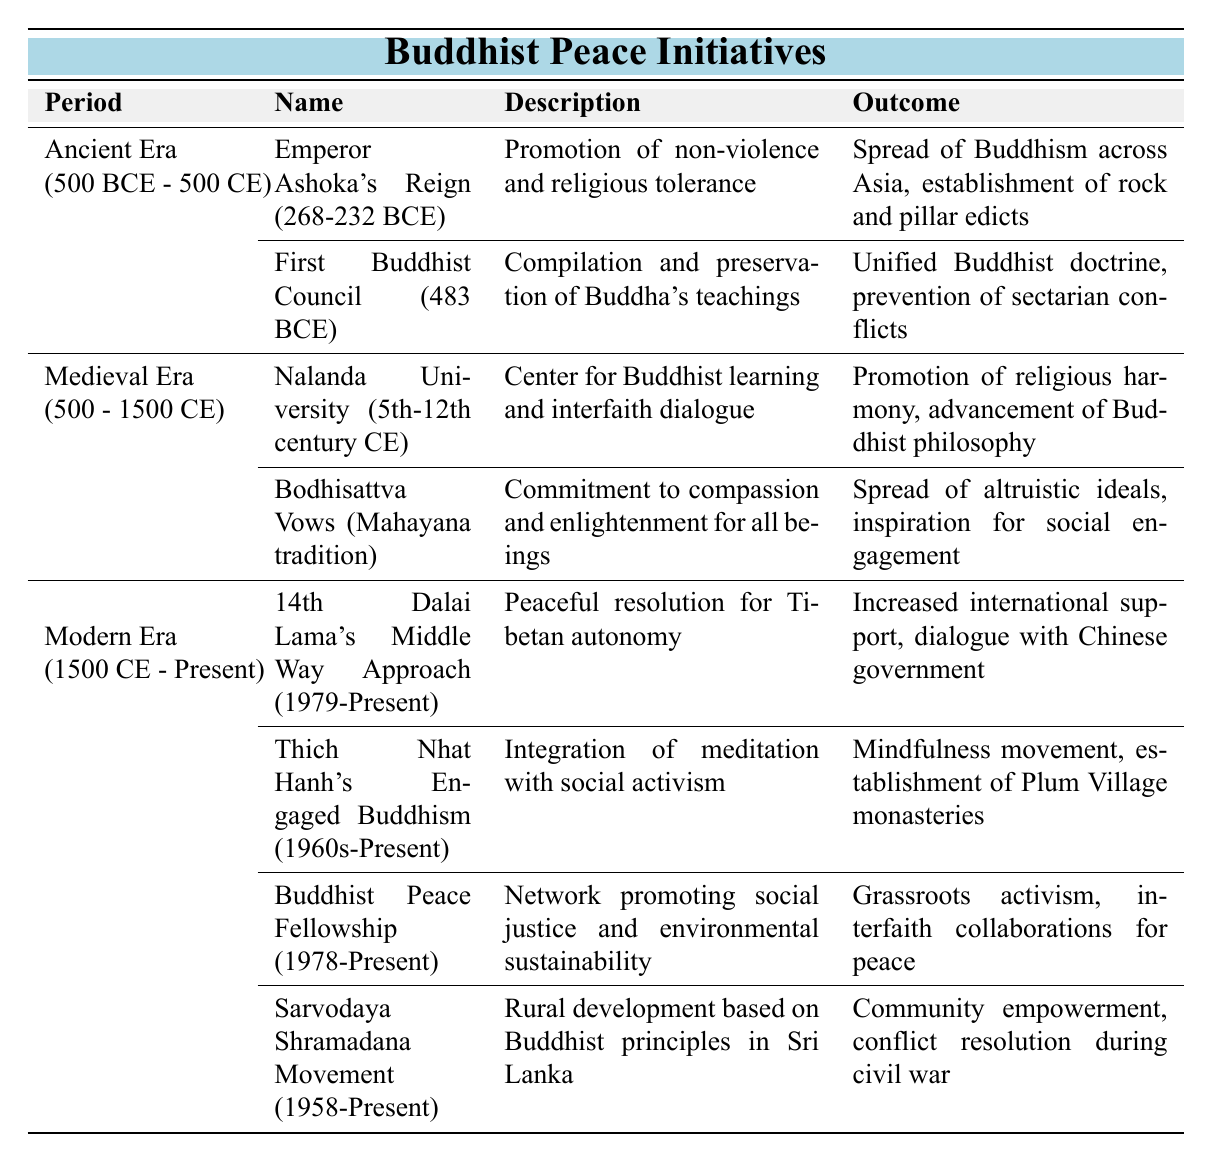What was the primary outcome of Emperor Ashoka's reign? The outcome of Emperor Ashoka's reign included the spread of Buddhism across Asia and the establishment of rock and pillar edicts which promoted non-violence and religious tolerance.
Answer: Spread of Buddhism across Asia, establishment of rock and pillar edicts Which initiative took place during the Medieval Era and focused on interfaith dialogue? The initiative during the Medieval Era that focused on interfaith dialogue was Nalanda University, which served as a center for Buddhist learning and promoted religious harmony.
Answer: Nalanda University How many initiatives are listed in the Modern Era? The Modern Era includes four initiatives: 14th Dalai Lama's Middle Way Approach, Thich Nhat Hanh's Engaged Buddhism, Buddhist Peace Fellowship, and Sarvodaya Shramadana Movement.
Answer: Four initiatives Did the Bodhisattva Vows promote social engagement? Yes, the Bodhisattva Vows inspired social engagement through the commitment to compassion and enlightenment for all beings.
Answer: Yes What is the common theme between the Sarvodaya Shramadana Movement and the Buddhist Peace Fellowship? Both the Sarvodaya Shramadana Movement and the Buddhist Peace Fellowship focus on community empowerment and social justice through Buddhist principles and activism.
Answer: Community empowerment and social justice What are the outcomes of Thich Nhat Hanh's initiative? Thich Nhat Hanh's initiative resulted in the mindfulness movement and the establishment of Plum Village monasteries, integrating meditation with social activism.
Answer: Mindfulness movement, establishment of Plum Village monasteries Which initiative had the earliest starting year in the Ancient Era? The earliest initiative in the Ancient Era is the First Buddhist Council, which took place in 483 BCE.
Answer: First Buddhist Council What was the longer-term effect of Emperor Ashoka's promotion of non-violence? The longer-term effect was a substantial spread of Buddhism across Asia and the establishment of structures like rock and pillar edicts, which emphasized religious tolerance.
Answer: Spread of Buddhism across Asia Is the 14th Dalai Lama's Middle Way Approach aimed at a peaceful resolution for Tibetan autonomy? Yes, it specifically aims for a peaceful resolution regarding Tibetan autonomy through ongoing dialogue and increased international support.
Answer: Yes Which two initiatives mention the concept of social engagement? The two initiatives that mention social engagement are Thich Nhat Hanh's Engaged Buddhism and the Buddhist Peace Fellowship.
Answer: Thich Nhat Hanh's Engaged Buddhism and the Buddhist Peace Fellowship 